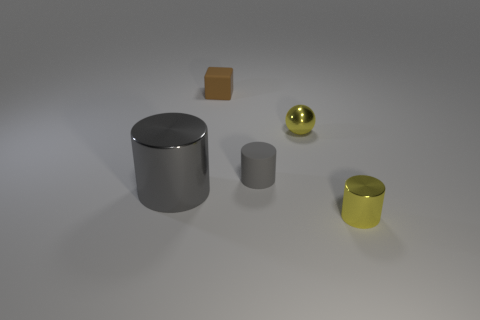What time of day does the lighting in this image suggest? The lighting in the image appears diffuse, with soft shadows indicating an overcast sky or indoor lighting with multiple sources that soften and spread out the shadows. It doesn't strongly suggest a particular time of day but is consistent with a controlled indoor environment. How could that affect the appearance of the objects? Under such even lighting, the objects' colors exhibit minimal distortion from shadows or highlights, allowing their true colors to be more apparent. The reflective properties of the metallic surfaces are also more evident, as the broad light source highlights their shininess and texture. 